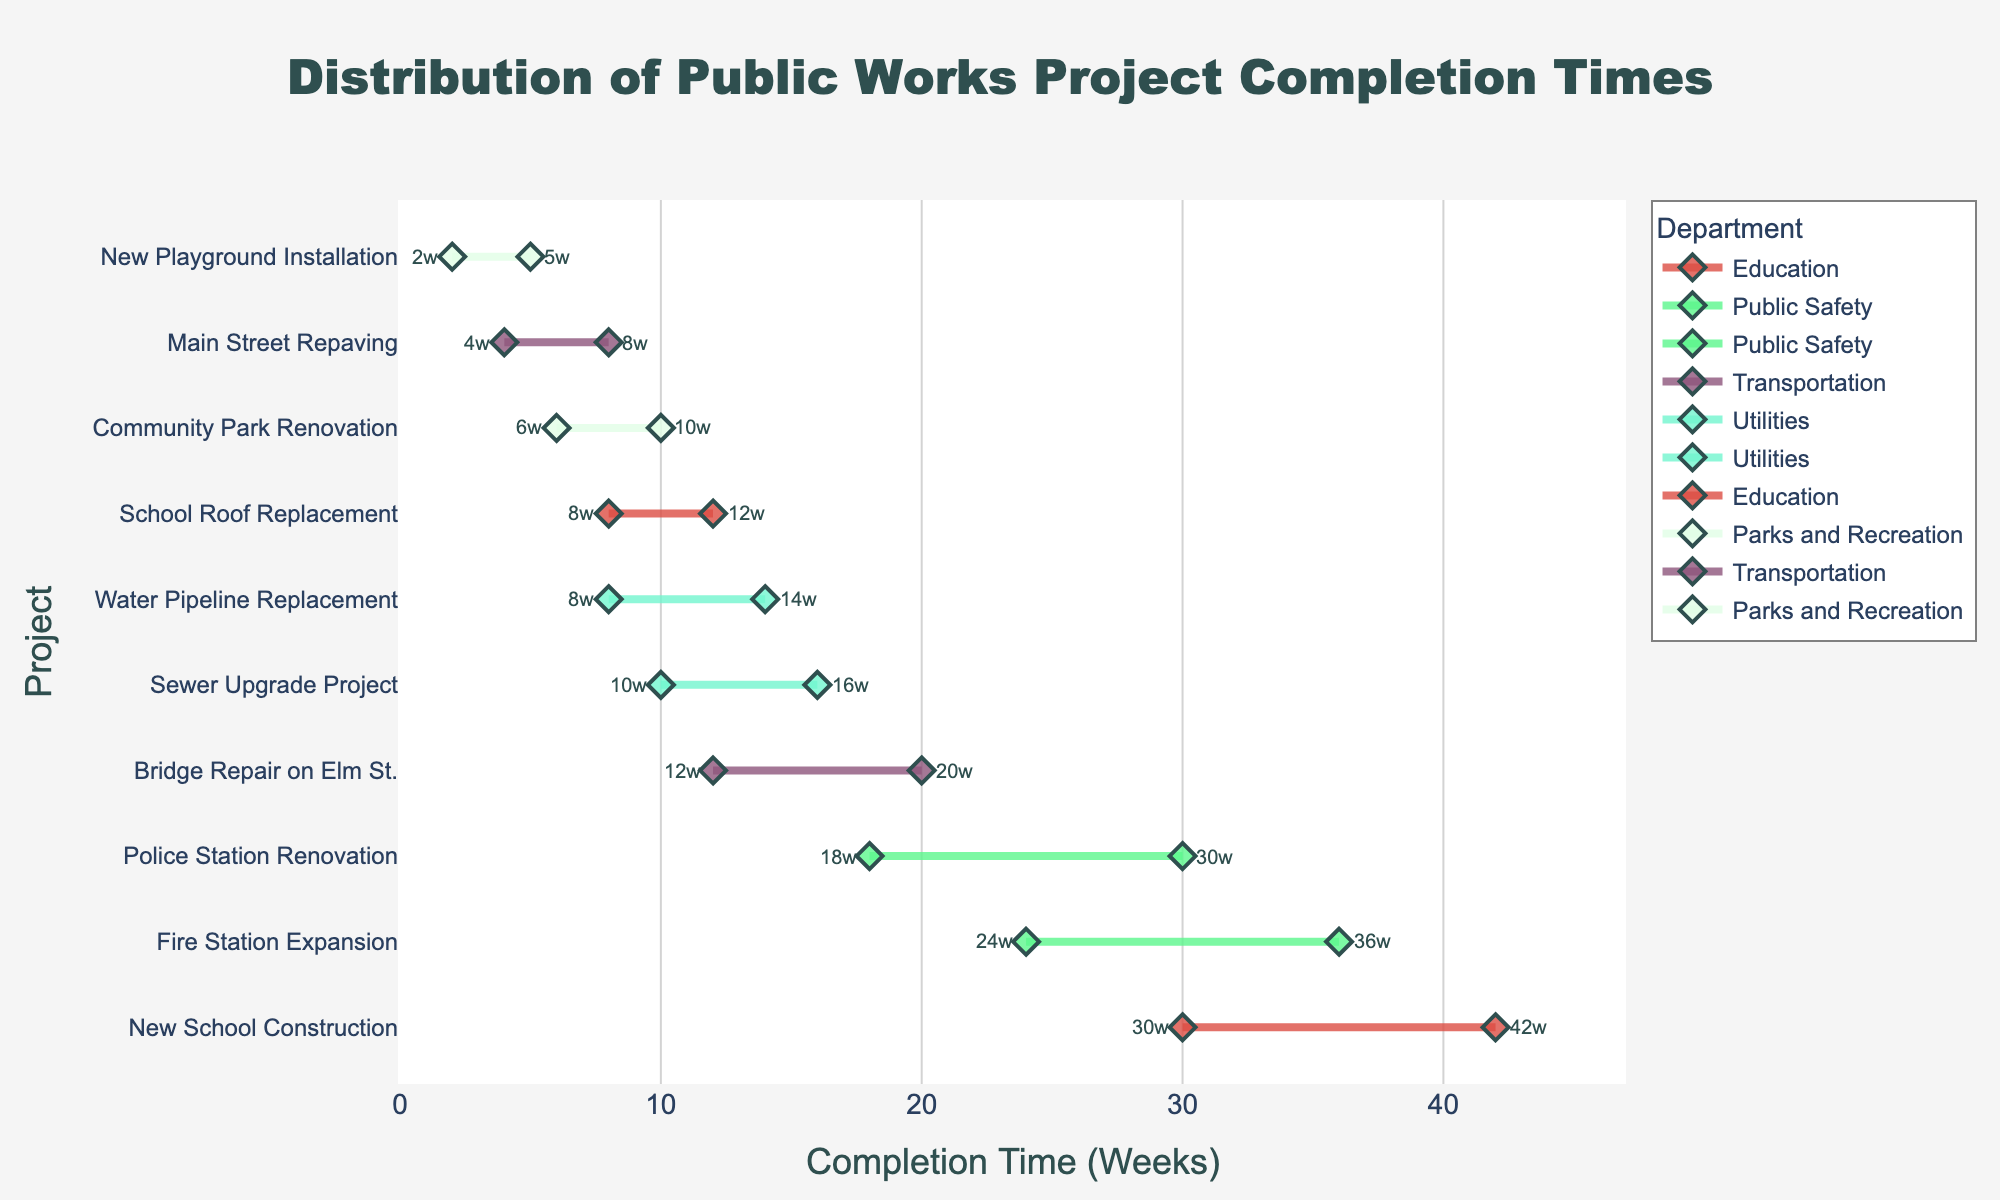What is the title of the plot? The title of the plot is located at the top of the figure. It gives an overview of what the plot represents.
Answer: Distribution of Public Works Project Completion Times Which project has the longest maximum completion time? By looking at the figures on the x-axis and the ends of the lines, we can determine that the project with the longest maximum completion time is the one with the highest end point.
Answer: New School Construction What is the range of completion time for the Fire Station Expansion project? The range can be found by subtracting the minimum completion time from the maximum completion time for the Fire Station Expansion project. It extends from 24 weeks to 36 weeks. So, 36 - 24 = 12 weeks.
Answer: 12 weeks Which department has the most projects listed? Count the number of projects listed for each department by looking at the colors and lines associated with each department. The department with the most projects listed will have the highest count.
Answer: Transportation and Parks and Recreation (tie) How does the completion time range of the Sewer Upgrade Project compare to the Community Park Renovation? Compare the start and end points of the lines representing these two projects. The Sewer Upgrade Project ranges from 10 to 16 weeks, and the Community Park Renovation ranges from 6 to 10 weeks. The comparison shows Sewer Upgrade has a wider and later range.
Answer: Sewer Upgrade Project has a wider and later range What's the average completion time for the New School Construction project? The average completion time is calculated by taking the midpoint between the minimum and maximum completion times. For New School Construction, we have (30+42)/2 = 36 weeks.
Answer: 36 weeks Which project has the smallest range of completion times? The smallest range can be determined by identifying the project with the smallest difference between its maximum and minimum completion times. The New Playground Installation has a range from 2 to 5 weeks, which is 5 - 2 = 3 weeks.
Answer: New Playground Installation What is the minimum and maximum completion time for the Bridge Repair on Elm St. project? The minimum and maximum completion times can be read directly from the end points of the line representing this project.
Answer: 12 weeks and 20 weeks Which department handles projects with a generally shorter completion time? By examining the range bars, we can see that Parks and Recreation has projects with shorter completion times compared to other departments, with ranges of 2-5 weeks and 6-10 weeks.
Answer: Parks and Recreation 